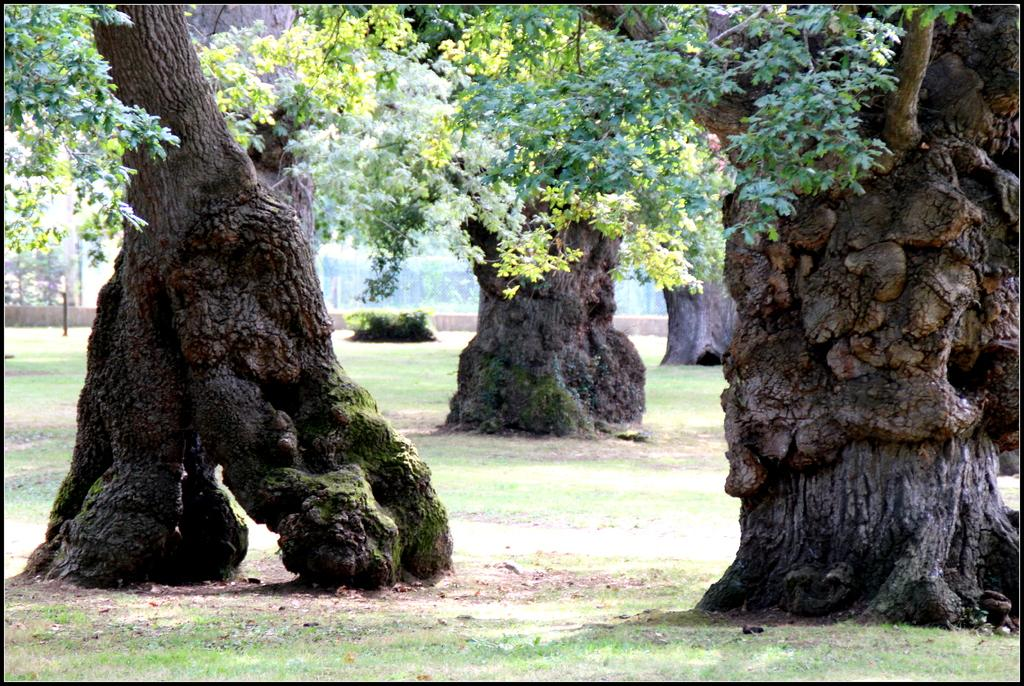What type of vegetation can be seen on the ground in the image? There are trees on the ground in the image. What other type of vegetation is visible in the image? There is grass visible in the image. Are there any other types of plants in the image? Yes, there are plants in the image. Can you describe any other items in the image besides the vegetation? There are other unspecified items in the image. What key is used to unlock the door in the image? There is no door or key present in the image; it only features trees, grass, plants, and unspecified items. How does the rock affect the growth of the plants in the image? There is no rock present in the image, so it cannot affect the growth of the plants. 